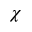Convert formula to latex. <formula><loc_0><loc_0><loc_500><loc_500>\chi</formula> 